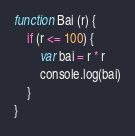<code> <loc_0><loc_0><loc_500><loc_500><_JavaScript_>function Bai (r) {
    if (r <= 100) {
        var bai = r * r
        console.log(bai)
    }
}</code> 